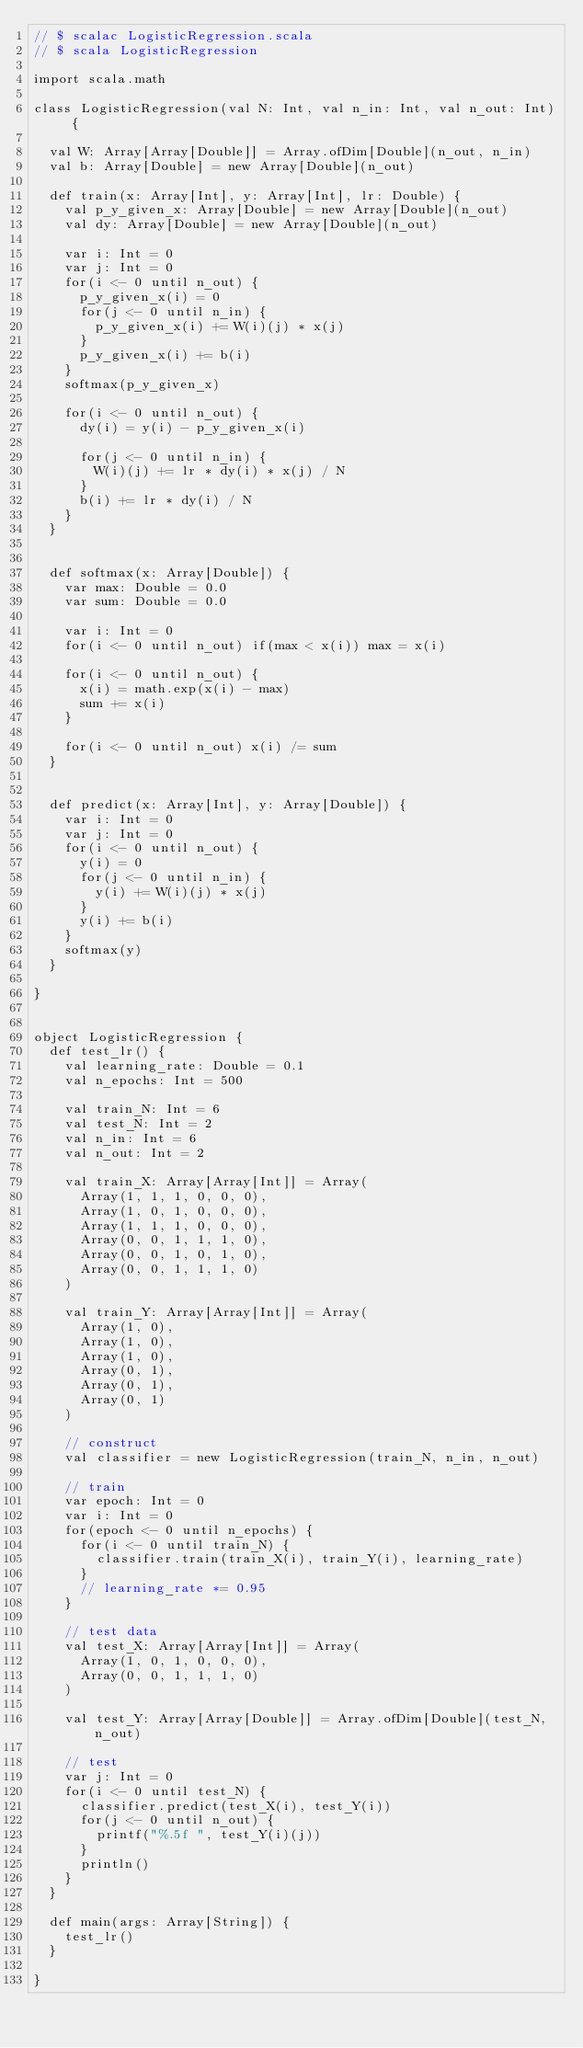<code> <loc_0><loc_0><loc_500><loc_500><_Scala_>// $ scalac LogisticRegression.scala
// $ scala LogisticRegression

import scala.math

class LogisticRegression(val N: Int, val n_in: Int, val n_out: Int) {

  val W: Array[Array[Double]] = Array.ofDim[Double](n_out, n_in)
  val b: Array[Double] = new Array[Double](n_out)

  def train(x: Array[Int], y: Array[Int], lr: Double) {
    val p_y_given_x: Array[Double] = new Array[Double](n_out)
    val dy: Array[Double] = new Array[Double](n_out)

    var i: Int = 0
    var j: Int = 0
    for(i <- 0 until n_out) {
      p_y_given_x(i) = 0
      for(j <- 0 until n_in) {
        p_y_given_x(i) += W(i)(j) * x(j)
      }
      p_y_given_x(i) += b(i)
    }
    softmax(p_y_given_x)

    for(i <- 0 until n_out) {
      dy(i) = y(i) - p_y_given_x(i)

      for(j <- 0 until n_in) {
        W(i)(j) += lr * dy(i) * x(j) / N
      }
      b(i) += lr * dy(i) / N
    }
  }


  def softmax(x: Array[Double]) {
    var max: Double = 0.0
    var sum: Double = 0.0

    var i: Int = 0
    for(i <- 0 until n_out) if(max < x(i)) max = x(i)

    for(i <- 0 until n_out) {
      x(i) = math.exp(x(i) - max)
      sum += x(i)
    }

    for(i <- 0 until n_out) x(i) /= sum
  }


  def predict(x: Array[Int], y: Array[Double]) {
    var i: Int = 0
    var j: Int = 0
    for(i <- 0 until n_out) {
      y(i) = 0
      for(j <- 0 until n_in) {
        y(i) += W(i)(j) * x(j)
      }
      y(i) += b(i)
    }
    softmax(y)
  }

}


object LogisticRegression {
  def test_lr() {
    val learning_rate: Double = 0.1
    val n_epochs: Int = 500

    val train_N: Int = 6
    val test_N: Int = 2
    val n_in: Int = 6
    val n_out: Int = 2

    val train_X: Array[Array[Int]] = Array(
      Array(1, 1, 1, 0, 0, 0),
      Array(1, 0, 1, 0, 0, 0),
      Array(1, 1, 1, 0, 0, 0),
      Array(0, 0, 1, 1, 1, 0),
      Array(0, 0, 1, 0, 1, 0),
      Array(0, 0, 1, 1, 1, 0)
    )

    val train_Y: Array[Array[Int]] = Array(
      Array(1, 0),
      Array(1, 0),
      Array(1, 0),
      Array(0, 1),
      Array(0, 1),
      Array(0, 1)
    )

    // construct
    val classifier = new LogisticRegression(train_N, n_in, n_out)

    // train
    var epoch: Int = 0
    var i: Int = 0
    for(epoch <- 0 until n_epochs) {
      for(i <- 0 until train_N) {
        classifier.train(train_X(i), train_Y(i), learning_rate)
      }
      // learning_rate *= 0.95
    }

    // test data
    val test_X: Array[Array[Int]] = Array(
      Array(1, 0, 1, 0, 0, 0),
      Array(0, 0, 1, 1, 1, 0)
    )

    val test_Y: Array[Array[Double]] = Array.ofDim[Double](test_N, n_out)

    // test
    var j: Int = 0
    for(i <- 0 until test_N) {
      classifier.predict(test_X(i), test_Y(i))
      for(j <- 0 until n_out) {
        printf("%.5f ", test_Y(i)(j))
      }
      println()
    }
  }

  def main(args: Array[String]) {
    test_lr()
  }

}
</code> 